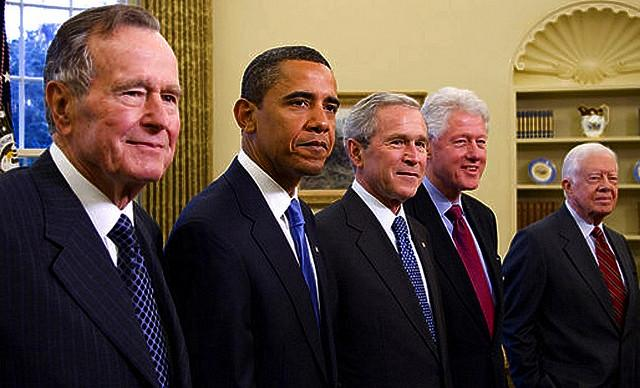What do these men have in common? presidents 